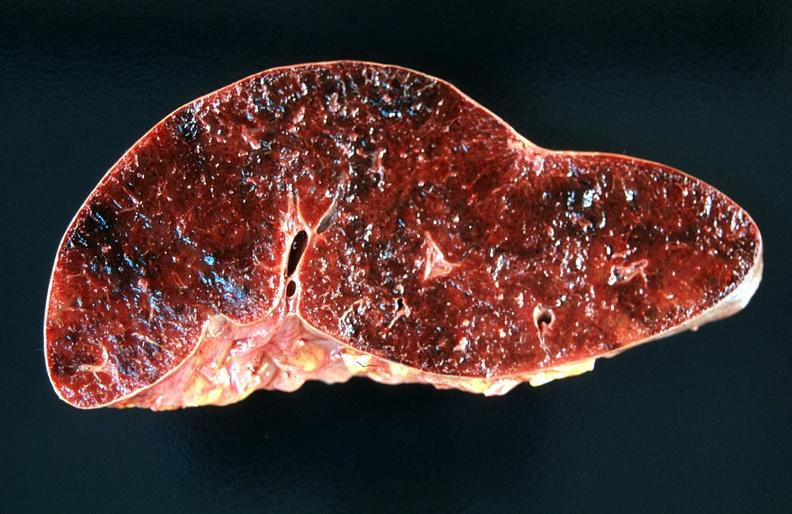s hematologic present?
Answer the question using a single word or phrase. Yes 